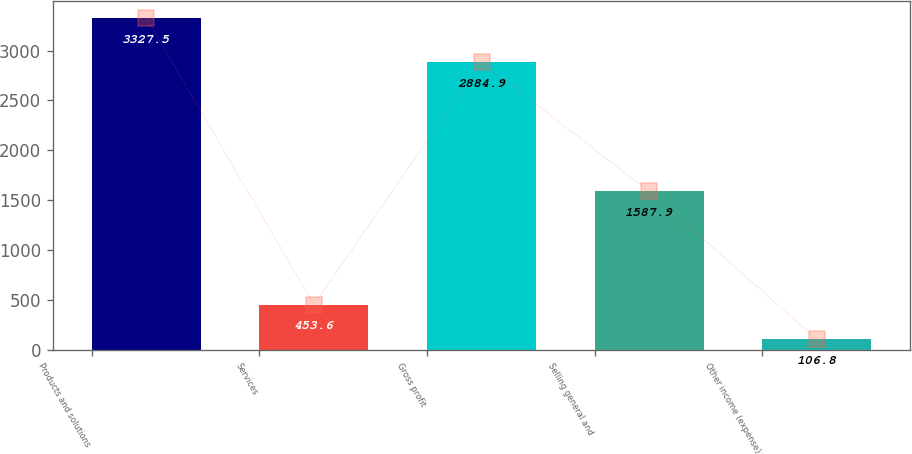Convert chart to OTSL. <chart><loc_0><loc_0><loc_500><loc_500><bar_chart><fcel>Products and solutions<fcel>Services<fcel>Gross profit<fcel>Selling general and<fcel>Other income (expense)<nl><fcel>3327.5<fcel>453.6<fcel>2884.9<fcel>1587.9<fcel>106.8<nl></chart> 